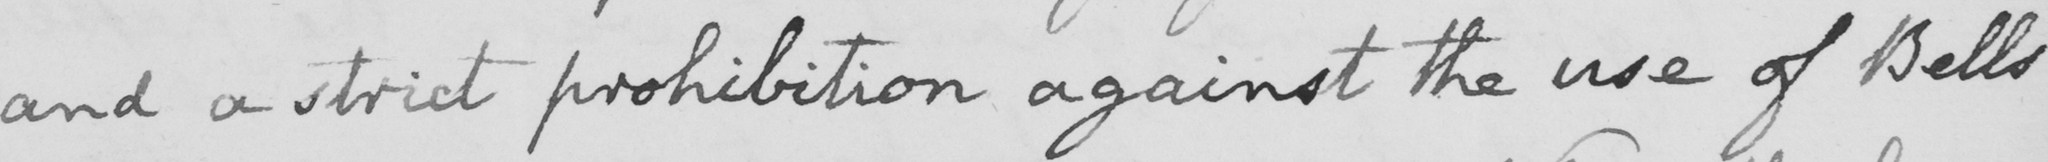Please provide the text content of this handwritten line. and a strict prohibition against the use of Bells 